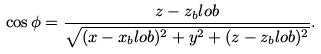Convert formula to latex. <formula><loc_0><loc_0><loc_500><loc_500>\cos \phi = \frac { z - z _ { b } l o b } { \sqrt { ( x - x _ { b } l o b ) ^ { 2 } + y ^ { 2 } + ( z - z _ { b } l o b ) ^ { 2 } } } .</formula> 